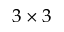Convert formula to latex. <formula><loc_0><loc_0><loc_500><loc_500>3 \times 3</formula> 